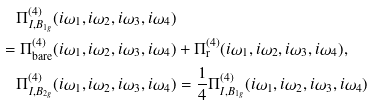Convert formula to latex. <formula><loc_0><loc_0><loc_500><loc_500>\Pi ^ { ( 4 ) } _ { I , B _ { 1 g } } ( i \omega _ { 1 } , i \omega _ { 2 } , i \omega _ { 3 } , i \omega _ { 4 } ) & \\ = \Pi ^ { ( 4 ) } _ { \text {bare} } ( i \omega _ { 1 } , i \omega _ { 2 } , i \omega _ { 3 } , i \omega _ { 4 } ) & + \Pi ^ { ( 4 ) } _ { \text {r} } ( i \omega _ { 1 } , i \omega _ { 2 } , i \omega _ { 3 } , i \omega _ { 4 } ) , \\ \Pi ^ { ( 4 ) } _ { I , B _ { 2 g } } ( i \omega _ { 1 } , i \omega _ { 2 } , i \omega _ { 3 } , i \omega _ { 4 } ) & = \frac { 1 } { 4 } \Pi ^ { ( 4 ) } _ { I , B _ { 1 g } } ( i \omega _ { 1 } , i \omega _ { 2 } , i \omega _ { 3 } , i \omega _ { 4 } )</formula> 